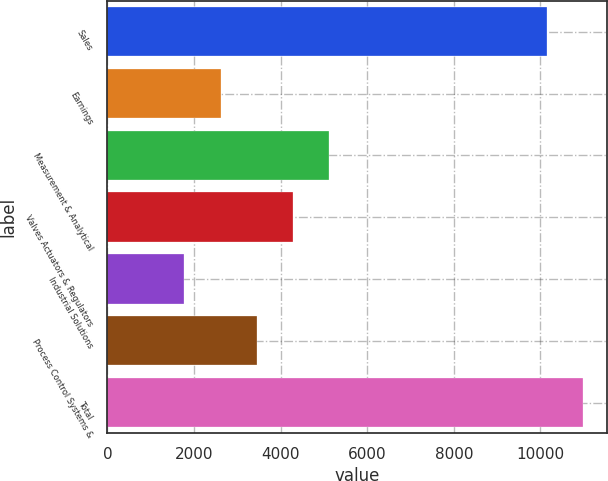Convert chart to OTSL. <chart><loc_0><loc_0><loc_500><loc_500><bar_chart><fcel>Sales<fcel>Earnings<fcel>Measurement & Analytical<fcel>Valves Actuators & Regulators<fcel>Industrial Solutions<fcel>Process Control Systems &<fcel>Total<nl><fcel>10153<fcel>2616.4<fcel>5128.6<fcel>4291.2<fcel>1779<fcel>3453.8<fcel>10990.4<nl></chart> 